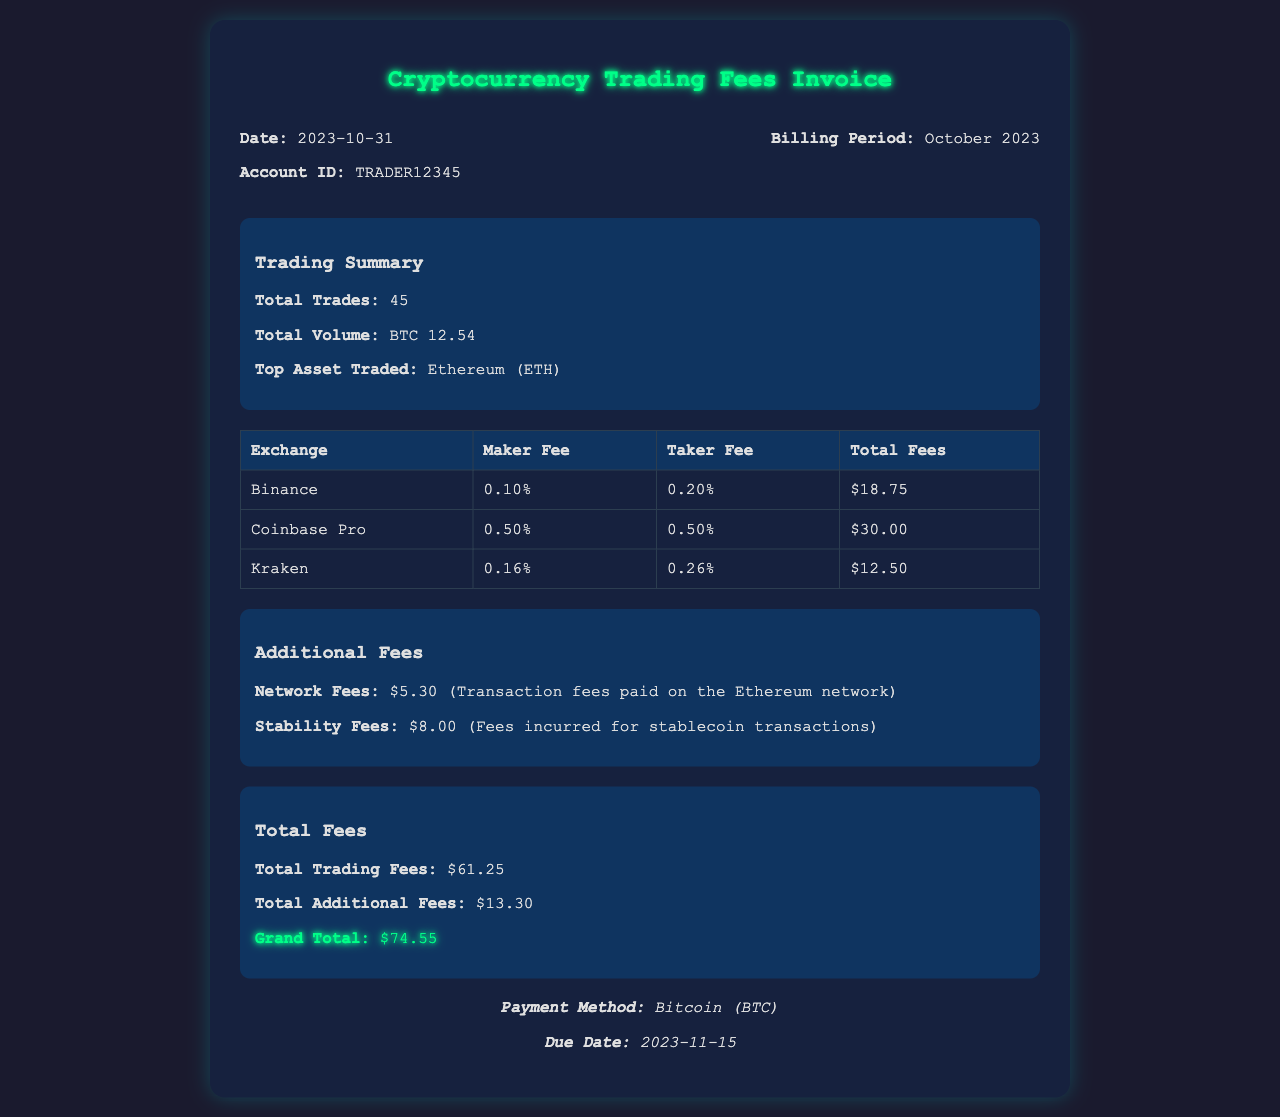what is the date of the invoice? The date of the invoice is clearly stated at the top of the document as 2023-10-31.
Answer: 2023-10-31 how many total trades were conducted? The total number of trades is summarized in the Trading Summary section, which shows a total of 45 trades.
Answer: 45 what is the top asset traded? The document mentions that the top asset traded is Ethereum (ETH) in the Trading Summary.
Answer: Ethereum (ETH) what are the total trading fees? The invoice calculates the total trading fees in the Total Fees section, where it lists the total trading fees as $61.25.
Answer: $61.25 what is the grand total of the invoice? The grand total is highlighted in the Total Fees section, which totals to $74.55.
Answer: $74.55 which exchange incurred the highest total fees? By reviewing the fees listed for each exchange, Coinbase Pro has the highest total fees at $30.00.
Answer: Coinbase Pro what are the additional fees listed? The document details two additional fees: Network Fees and Stability Fees, which cumulatively amount to $13.30.
Answer: $13.30 when is the payment due? The due date for payment is specified in the Payment Info section as 2023-11-15.
Answer: 2023-11-15 